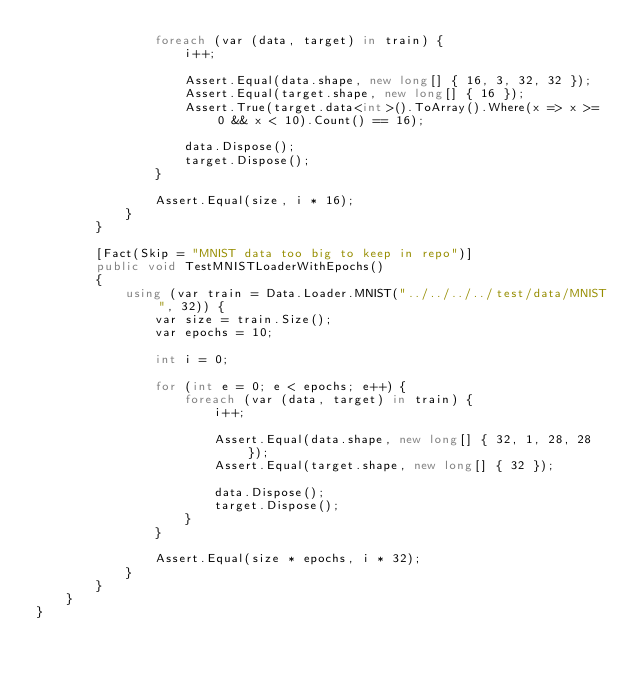Convert code to text. <code><loc_0><loc_0><loc_500><loc_500><_C#_>                foreach (var (data, target) in train) {
                    i++;

                    Assert.Equal(data.shape, new long[] { 16, 3, 32, 32 });
                    Assert.Equal(target.shape, new long[] { 16 });
                    Assert.True(target.data<int>().ToArray().Where(x => x >= 0 && x < 10).Count() == 16);

                    data.Dispose();
                    target.Dispose();
                }

                Assert.Equal(size, i * 16);
            }
        }

        [Fact(Skip = "MNIST data too big to keep in repo")]
        public void TestMNISTLoaderWithEpochs()
        {
            using (var train = Data.Loader.MNIST("../../../../test/data/MNIST", 32)) {
                var size = train.Size();
                var epochs = 10;

                int i = 0;

                for (int e = 0; e < epochs; e++) {
                    foreach (var (data, target) in train) {
                        i++;

                        Assert.Equal(data.shape, new long[] { 32, 1, 28, 28 });
                        Assert.Equal(target.shape, new long[] { 32 });

                        data.Dispose();
                        target.Dispose();
                    }
                }

                Assert.Equal(size * epochs, i * 32);
            }
        }
    }
}
</code> 